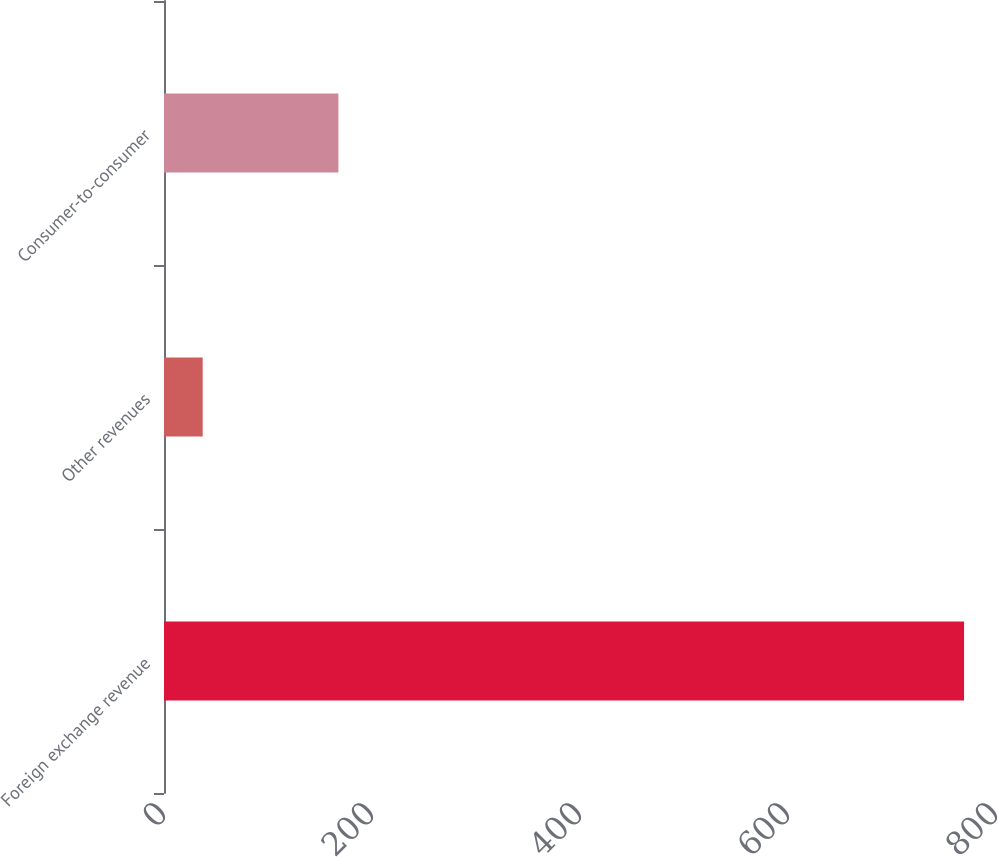<chart> <loc_0><loc_0><loc_500><loc_500><bar_chart><fcel>Foreign exchange revenue<fcel>Other revenues<fcel>Consumer-to-consumer<nl><fcel>769.3<fcel>37.2<fcel>167.7<nl></chart> 